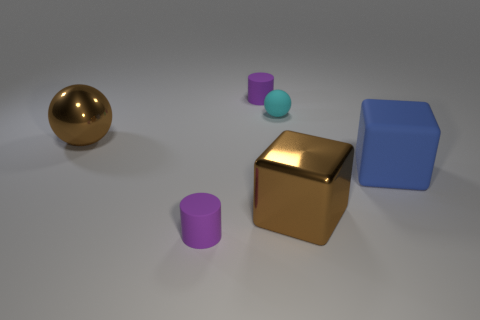Add 2 small rubber cylinders. How many objects exist? 8 Subtract all spheres. How many objects are left? 4 Subtract 1 balls. How many balls are left? 1 Subtract all yellow metallic spheres. Subtract all big balls. How many objects are left? 5 Add 4 matte things. How many matte things are left? 8 Add 3 brown shiny blocks. How many brown shiny blocks exist? 4 Subtract 0 yellow balls. How many objects are left? 6 Subtract all red cubes. Subtract all cyan spheres. How many cubes are left? 2 